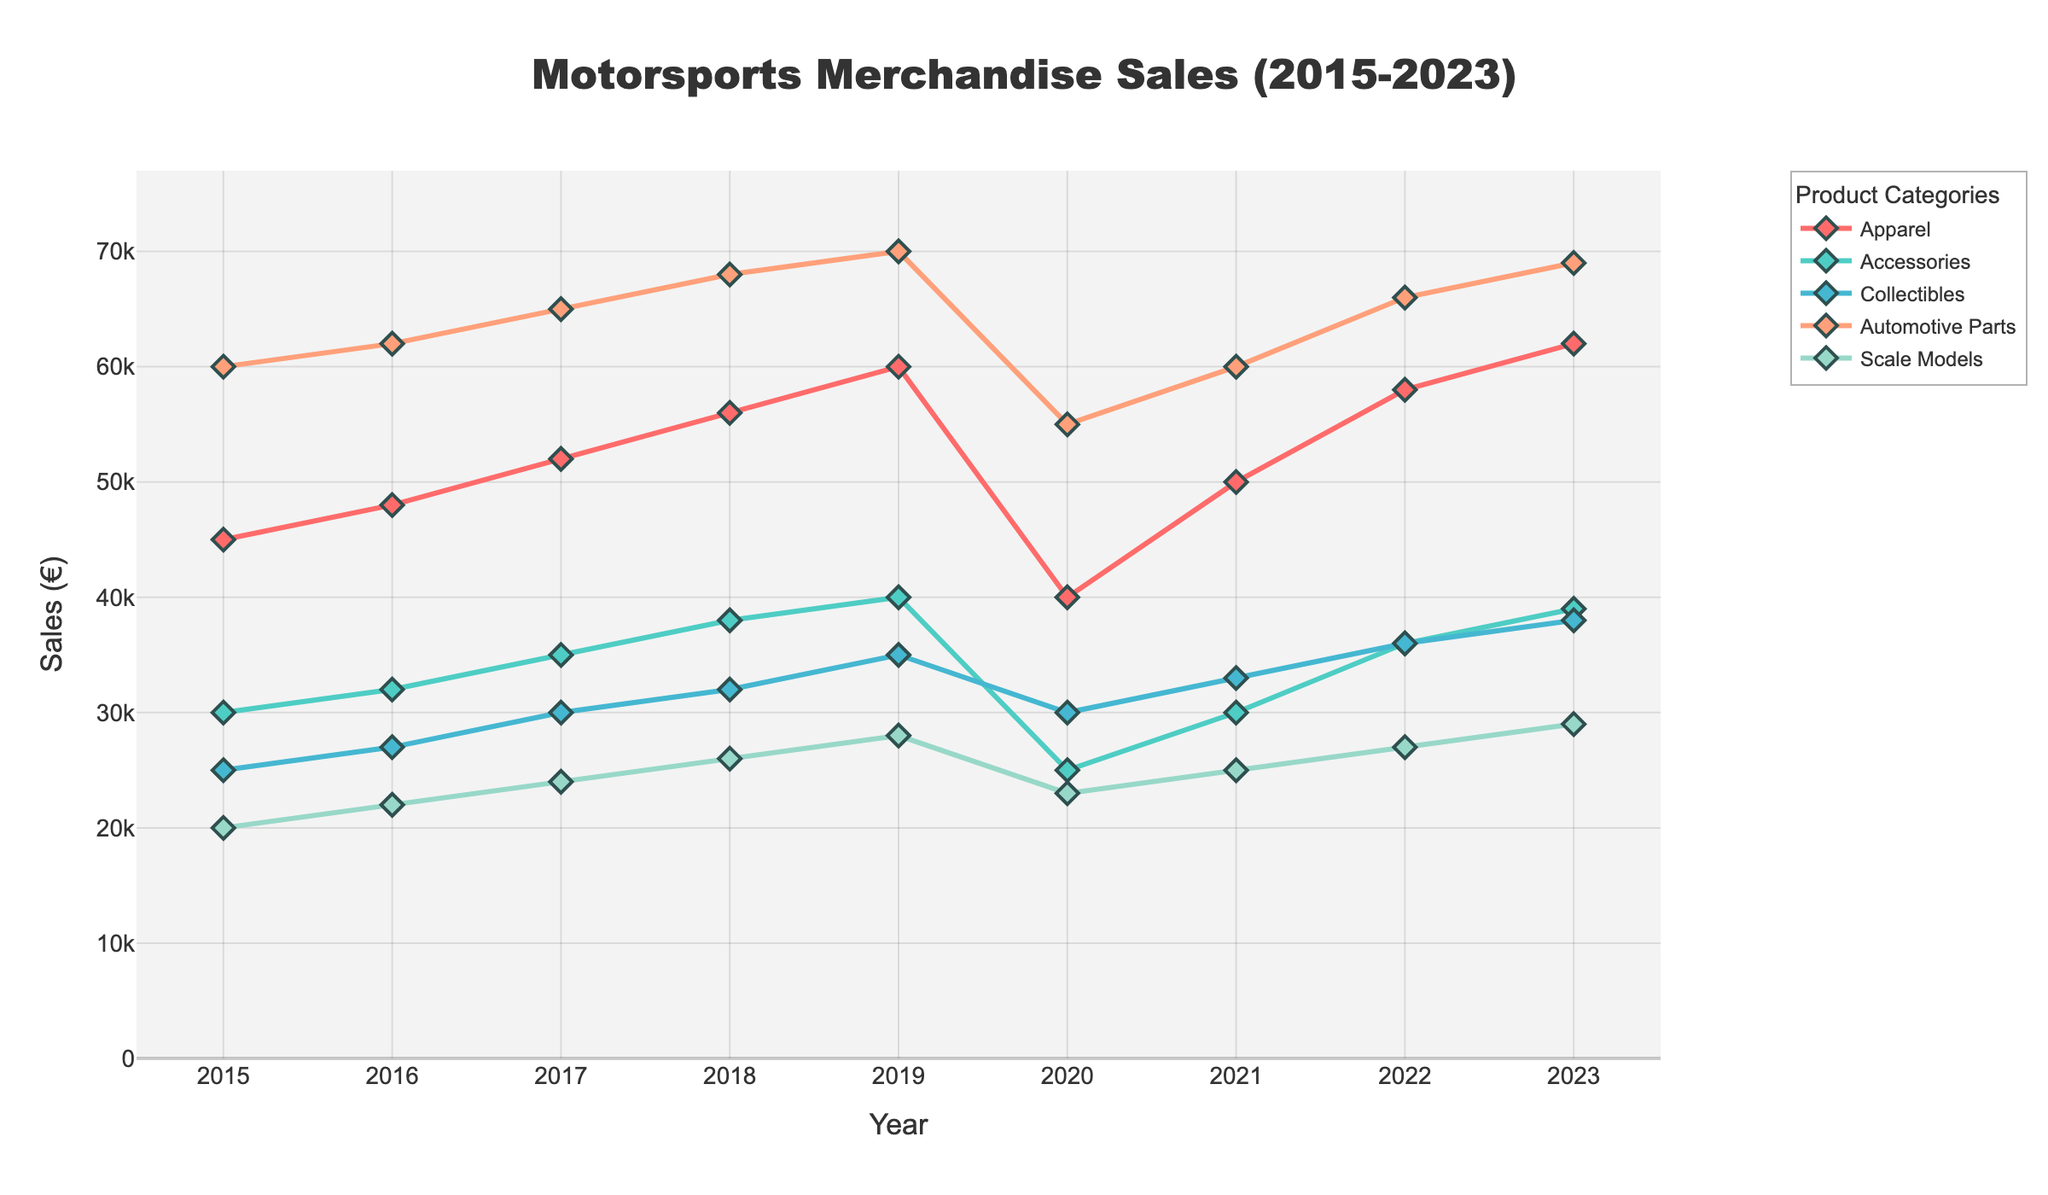Question2 Comparing 2020 and 2023, which category showed the highest increase in sales?
Answer: Calculate the difference in sales for each category between 2020 and 2023. The differences are: 
- Apparel: 62000 - 40000 = 22000
- Accessories: 39000 - 25000 = 14000
- Collectibles: 38000 - 30000 = 8000
- Automotive Parts: 69000 - 55000 = 14000
- Scale Models: 29000 - 23000 = 6000 Question3 Which category had the lowest sales in 2019 and what was the value?
Answer: Look at the sales values for each category in the year 2019: 
- Apparel: 60000
- Accessories: 40000
- Collectibles: 35000
- Automotive Parts: 70000
- Scale Models: 28000 Question5 Between which consecutive years did Automotive Parts experience the highest growth?
Answer: Calculate the year-over-year changes for Automotive Parts:
- 2016: 62000 - 60000 = 2000
- 2017: 65000 - 62000 = 3000
- 2018: 68000 - 65000 = 3000
- 2019: 70000 - 68000 = 2000
- 2020: 55000 - 70000 = -15000
- 2021: 60000 - 55000 = 5000
- 2022: 66000 - 60000 = 6000
- 2023: 69000 - 66000 = 3000 Question6 Which category had the most consistent sales growth over the years?
Answer: Consistent sales growth means having a relatively steady increase without major declines. By examining the graph lines:
- Apparel, Accessories, and Collectibles have relatively steady upward trends with minor fluctuations.
- Automotive Parts shows a significant drop in 2020.
- Scale Models have a relatively steady but slight increase Question7 In which year did the sales of Scale Models surpass 25000 for the first time?
Answer: Identify the year from the data where Scale Models' sales first exceed 25000:
- 2015: 20000
- 2016: 22000
- 2017: 24000
- 2018: 26000 Question9 Which year saw the biggest drop in sales for any single category, and which category was it?
Answer: Identify the largest year-over-year drop for each category and find the maximum:
- Apparel: 2020 (40000 - 60000 = -20000)
- Accessories: 2020 (25000 - 40000 = -15000)
- Collectibles: No significant drop
- Automotive Parts: 2020 (55000 - 70000 = -15000)
- Scale Models: 2020 (23000 - 28000 = -5000) 